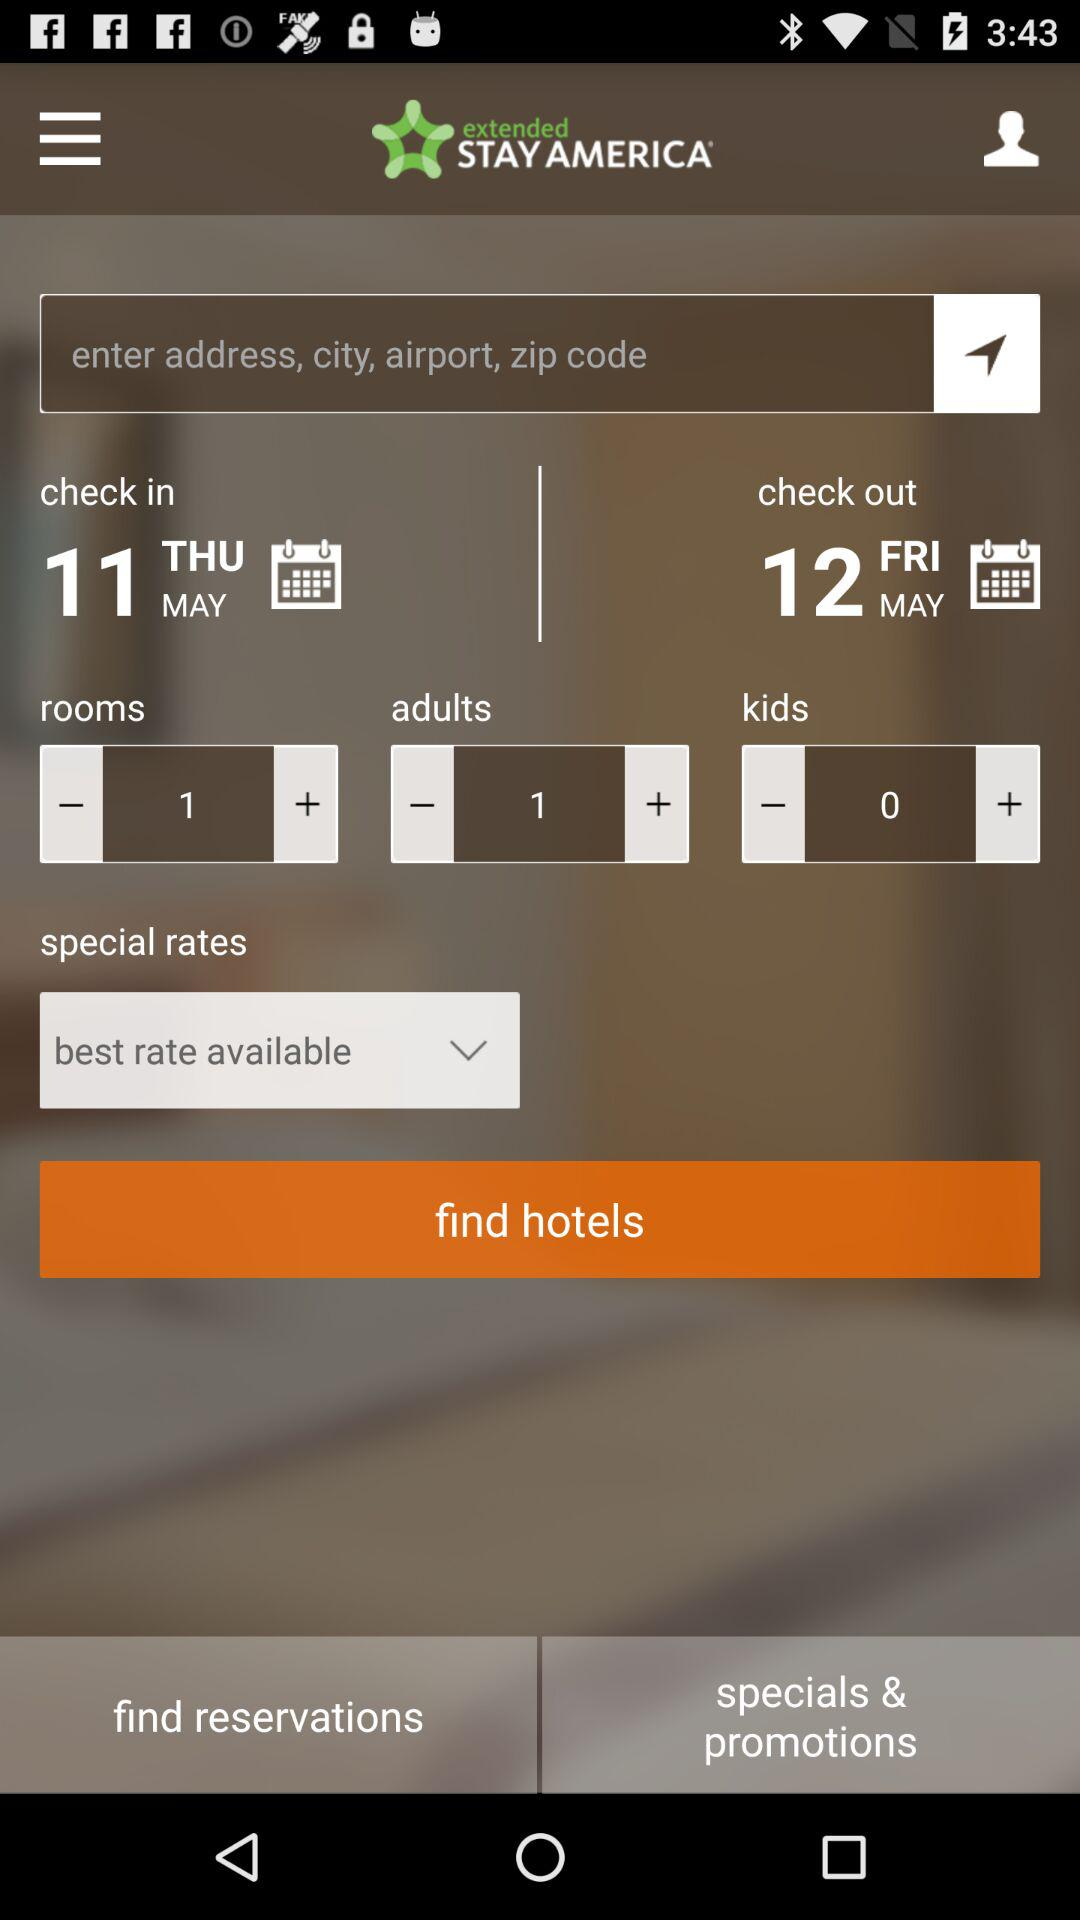How many more adults are there than kids?
Answer the question using a single word or phrase. 1 